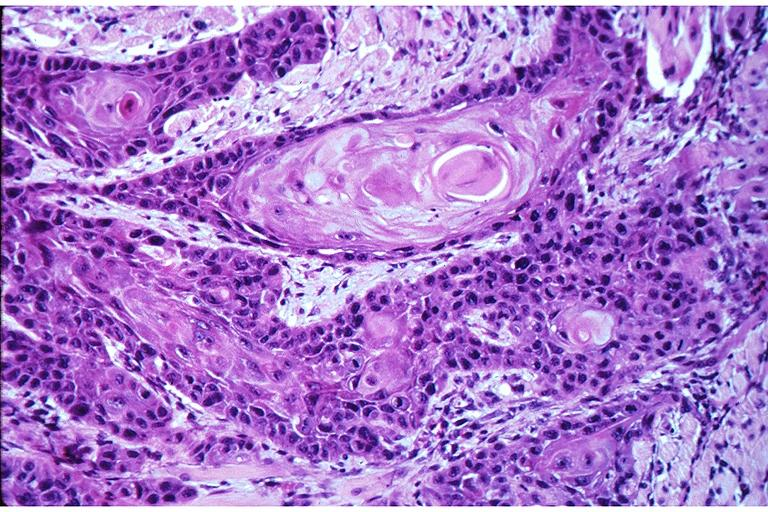does this image show squamous cell carcinoma?
Answer the question using a single word or phrase. Yes 